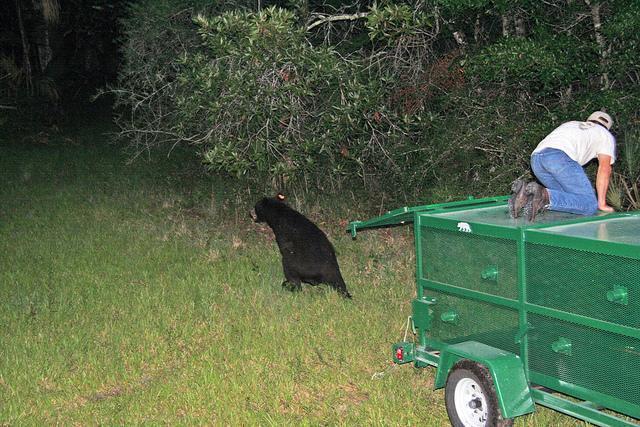How many wheels are in this picture?
Give a very brief answer. 1. 